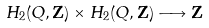Convert formula to latex. <formula><loc_0><loc_0><loc_500><loc_500>H _ { 2 } ( Q , \mathbf Z ) \times H _ { 2 } ( Q , \mathbf Z ) \longrightarrow \mathbf Z</formula> 